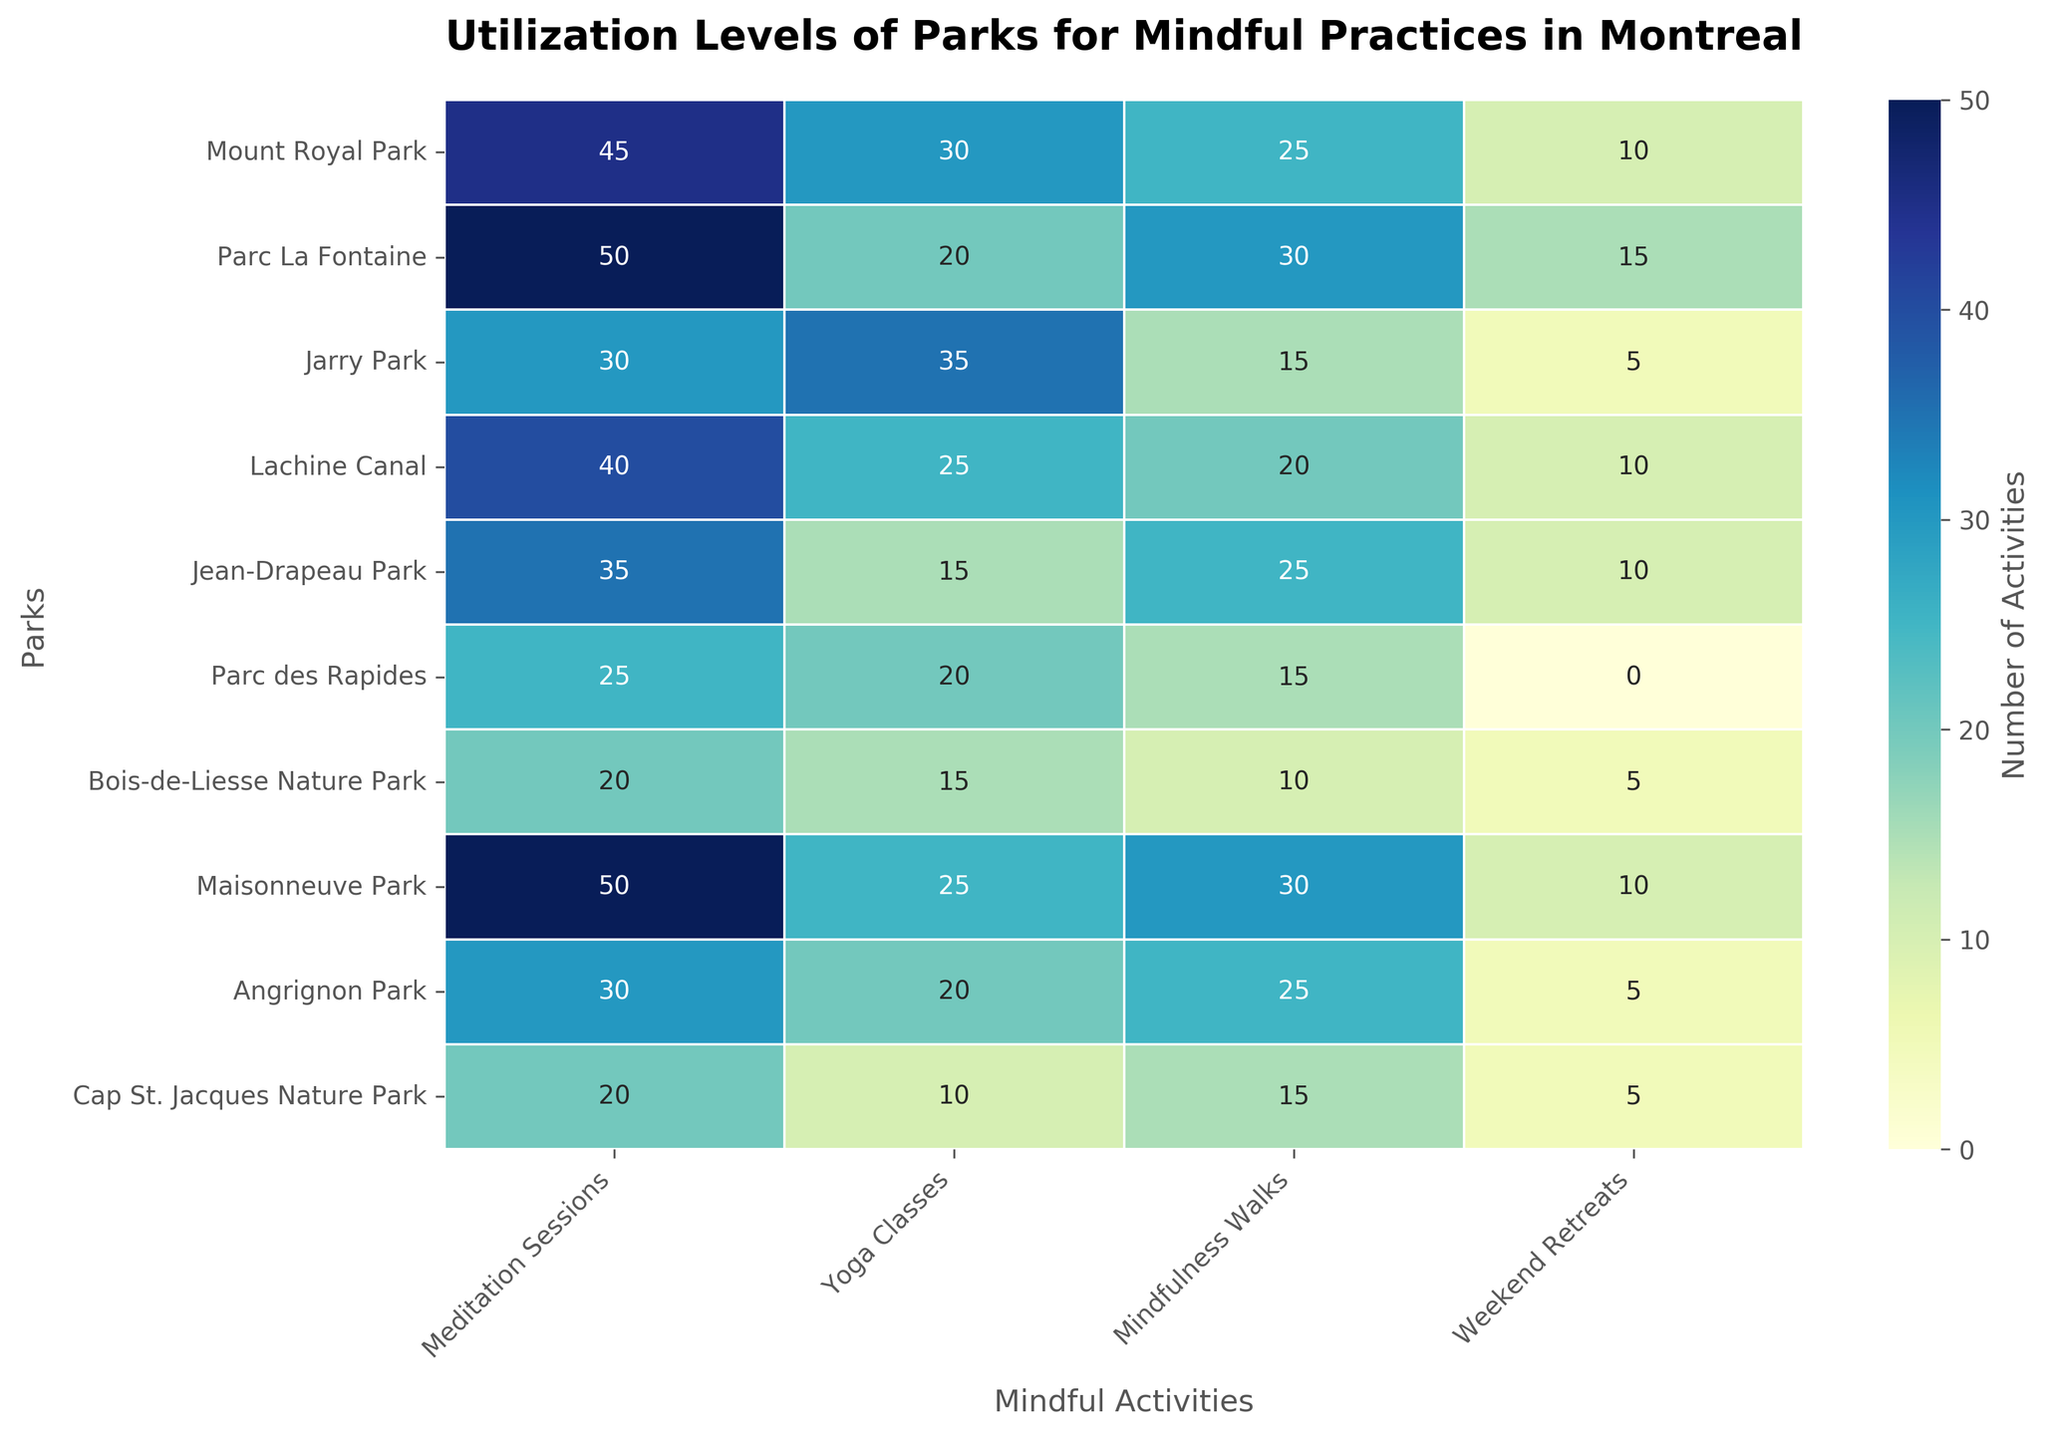What is the total number of Meditation Sessions across all parks? Add up the values in the "Meditation Sessions" column: 45 + 50 + 30 + 40 + 35 + 25 + 20 + 50 + 30 + 20 = 345
Answer: 345 Which park has the highest number of Yoga Classes? Look at the "Yoga Classes" column and find the highest value, which is 35. The corresponding park is "Jarry Park."
Answer: Jarry Park What is the average number of Weekend Retreats offered across all parks? Add the values in the "Weekend Retreats" column: 10 + 15 + 5 + 10 + 10 + 0 + 5 + 10 + 5 + 5. The total is 75, and there are 10 parks, so the average is 75 / 10 = 7.5
Answer: 7.5 Which activity has the lowest total utilization across all parks? Summarize each activity column: 
- Meditation Sessions: 345 
- Yoga Classes: 235 
- Mindfulness Walks: 220 
- Weekend Retreats: 75 
The activity with the lowest total is "Weekend Retreats."
Answer: Weekend Retreats How many more Meditation Sessions are there in Parc La Fontaine compared to Jean-Drapeau Park? Subtract the "Meditation Sessions" value of Jean-Drapeau Park from that of Parc La Fontaine: 50 - 35 = 15
Answer: 15 Which park offers the least Mindful Practices overall? Sum the values for each park. The park with the lowest total is "Cap St. Jacques Nature Park" with 50 sessions.
Answer: Cap St. Jacques Nature Park What's the difference in the number of Weekend Retreats between the park with the most and the park with the least? The highest value is 15 (Parc La Fontaine), and the lowest is 0 (Parc des Rapides). The difference is 15 - 0 = 15
Answer: 15 Based on the heatmap, which Nature Area is used most frequently across all activities? Sum the values per "Nature Area." Sum all corresponding parks in one area ensuring checking per attributed designation like Central Natural, Southern Natural to infer frequency usage. Conclude as "Southern Natural Area" from highest combining per nature area.
Answer: Southern Natural Area 